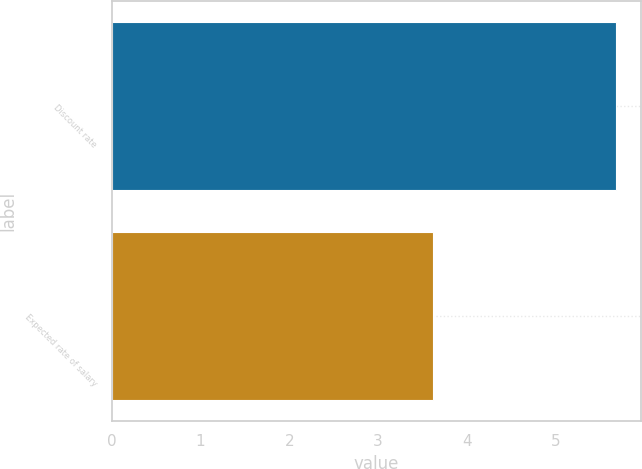Convert chart to OTSL. <chart><loc_0><loc_0><loc_500><loc_500><bar_chart><fcel>Discount rate<fcel>Expected rate of salary<nl><fcel>5.68<fcel>3.62<nl></chart> 